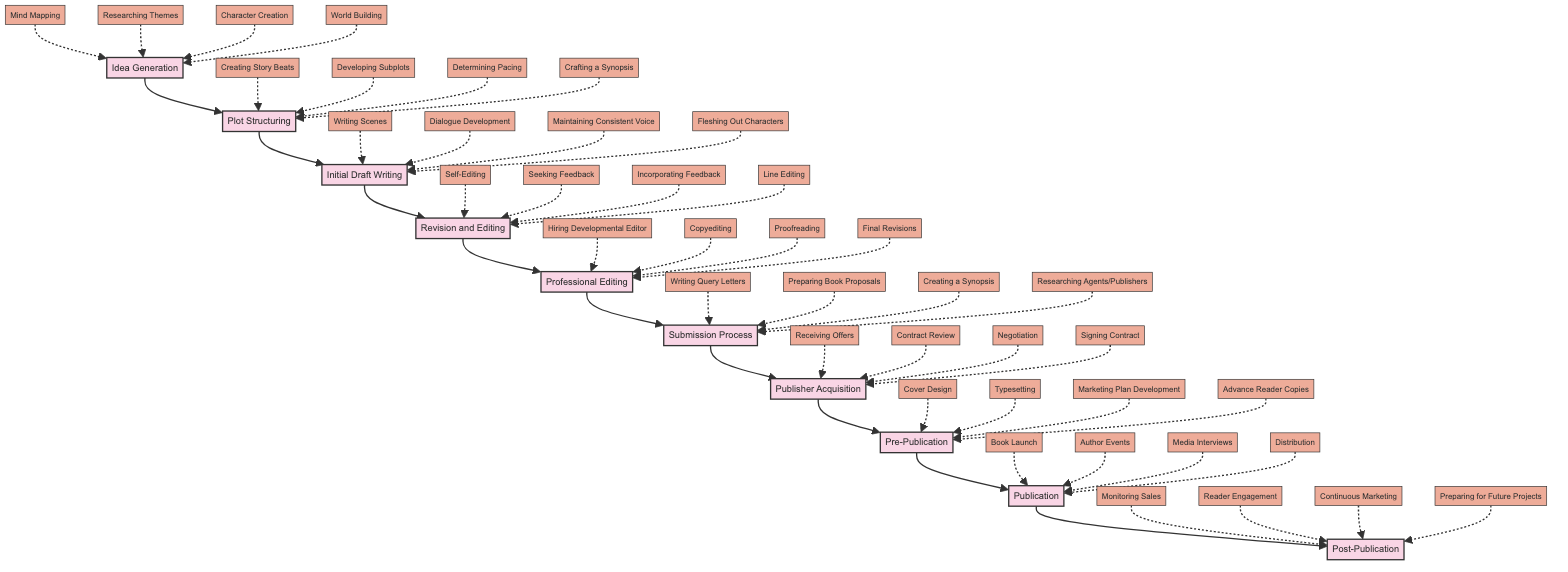What is the first stage in the novel writing process? The first stage, according to the diagram, is labeled "Idea Generation." It's the starting point of the entire writing process.
Answer: Idea Generation How many main stages are there in the process? By counting the stages from "Idea Generation" to "Post-Publication" in the diagram, we find there are ten distinct stages.
Answer: 10 What action is associated with the "Revision and Editing" stage? The actions listed under the "Revision and Editing" stage include several processes. For example, "Self-Editing" is one important action performed during this stage.
Answer: Self-Editing What follows the "Submission Process" stage? According to the flow of the diagram, after the "Submission Process," the next stage is "Publisher Acquisition." This shows the progression from preparing the manuscript to securing a publisher.
Answer: Publisher Acquisition Which stage includes "Cover Design"? The action "Cover Design" is explicitly listed under the "Pre-Publication" stage. This indicates preparations for the book's visual representation before it goes to print.
Answer: Pre-Publication What is the final stage in the diagram? The last stage shown in the diagram after the flow concludes is "Post-Publication," indicating ongoing tasks after the book has been released.
Answer: Post-Publication Which action involves feedback from readers? The action that involves reader feedback is "Seeking Feedback from Beta Readers," associated with the "Revision and Editing" stage, which emphasizes the importance of external input during revisions.
Answer: Seeking Feedback from Beta Readers What are the four actions shown in the "Initial Draft Writing" stage? The actions listed under "Initial Draft Writing" include "Writing Scenes," "Dialogue Development," "Maintaining Consistent Voice," and "Fleshing Out Characters," summarizing critical tasks for draft creation.
Answer: Writing Scenes, Dialogue Development, Maintaining Consistent Voice, Fleshing Out Characters How do the stages progress from "Plot Structuring" to "Initial Draft Writing"? The diagram shows a direct flow where "Plot Structuring" leads into "Initial Draft Writing." The transition highlights that organizing the plot logically sets the foundation for writing the actual draft.
Answer: Initial Draft Writing 